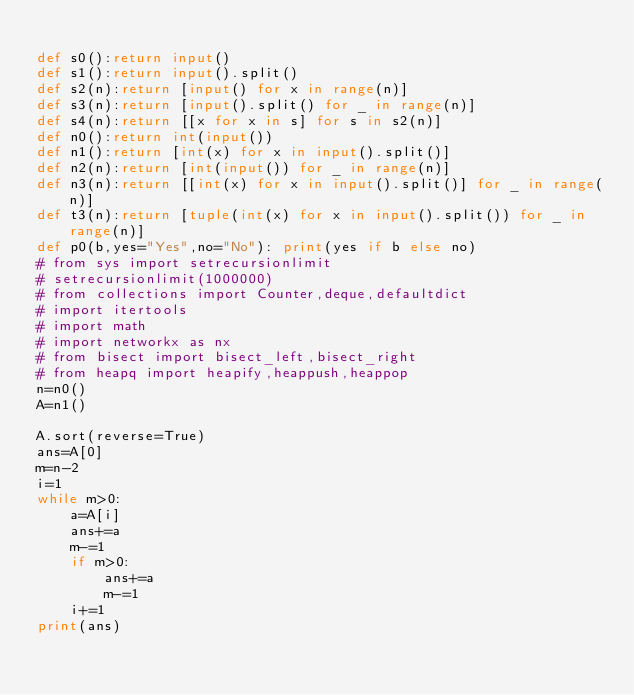<code> <loc_0><loc_0><loc_500><loc_500><_Python_>
def s0():return input()
def s1():return input().split()
def s2(n):return [input() for x in range(n)]
def s3(n):return [input().split() for _ in range(n)]
def s4(n):return [[x for x in s] for s in s2(n)]
def n0():return int(input())
def n1():return [int(x) for x in input().split()]
def n2(n):return [int(input()) for _ in range(n)]
def n3(n):return [[int(x) for x in input().split()] for _ in range(n)]
def t3(n):return [tuple(int(x) for x in input().split()) for _ in range(n)]
def p0(b,yes="Yes",no="No"): print(yes if b else no)
# from sys import setrecursionlimit
# setrecursionlimit(1000000)
# from collections import Counter,deque,defaultdict
# import itertools
# import math
# import networkx as nx
# from bisect import bisect_left,bisect_right
# from heapq import heapify,heappush,heappop
n=n0()
A=n1()

A.sort(reverse=True)
ans=A[0]
m=n-2
i=1
while m>0:
    a=A[i]
    ans+=a
    m-=1
    if m>0:
        ans+=a
        m-=1
    i+=1
print(ans)</code> 